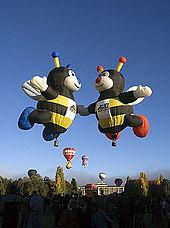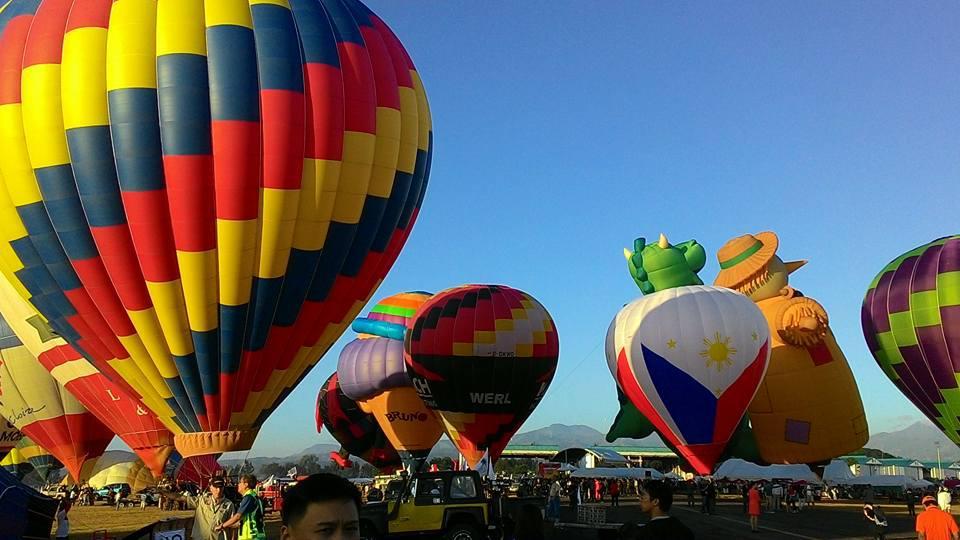The first image is the image on the left, the second image is the image on the right. Analyze the images presented: Is the assertion "There are hot air balloons floating over a body of water in the right image." valid? Answer yes or no. No. The first image is the image on the left, the second image is the image on the right. Evaluate the accuracy of this statement regarding the images: "At least one balloon is shaped like an animal with legs.". Is it true? Answer yes or no. Yes. 